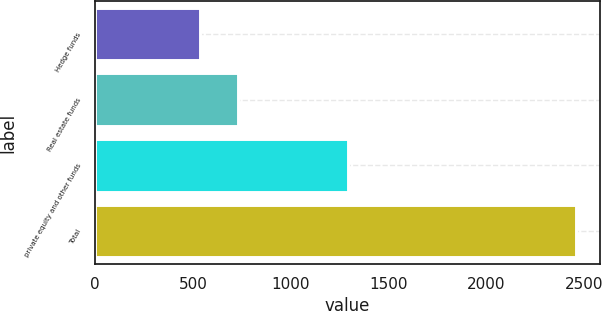Convert chart to OTSL. <chart><loc_0><loc_0><loc_500><loc_500><bar_chart><fcel>Hedge funds<fcel>Real estate funds<fcel>private equity and other funds<fcel>Total<nl><fcel>536<fcel>728<fcel>1291<fcel>2456<nl></chart> 